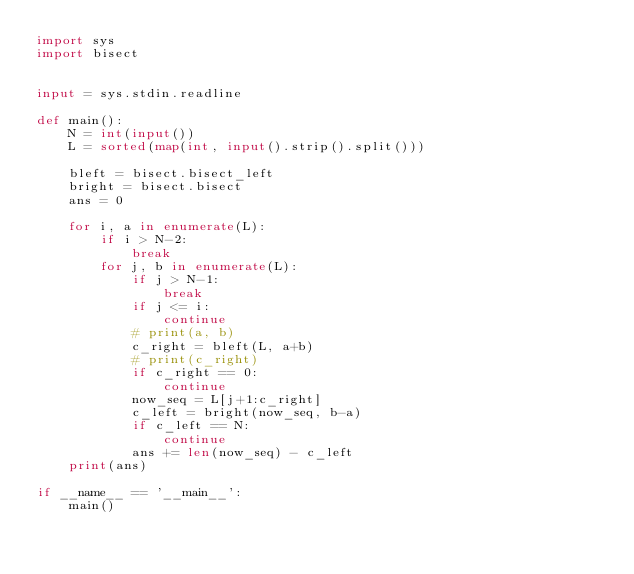<code> <loc_0><loc_0><loc_500><loc_500><_Python_>import sys
import bisect


input = sys.stdin.readline

def main():
    N = int(input())
    L = sorted(map(int, input().strip().split()))

    bleft = bisect.bisect_left
    bright = bisect.bisect
    ans = 0

    for i, a in enumerate(L):
        if i > N-2:
            break
        for j, b in enumerate(L):
            if j > N-1:
                break
            if j <= i:
                continue
            # print(a, b)
            c_right = bleft(L, a+b)
            # print(c_right)
            if c_right == 0:
                continue
            now_seq = L[j+1:c_right]
            c_left = bright(now_seq, b-a)
            if c_left == N:
                continue
            ans += len(now_seq) - c_left
    print(ans)

if __name__ == '__main__':
    main()
</code> 